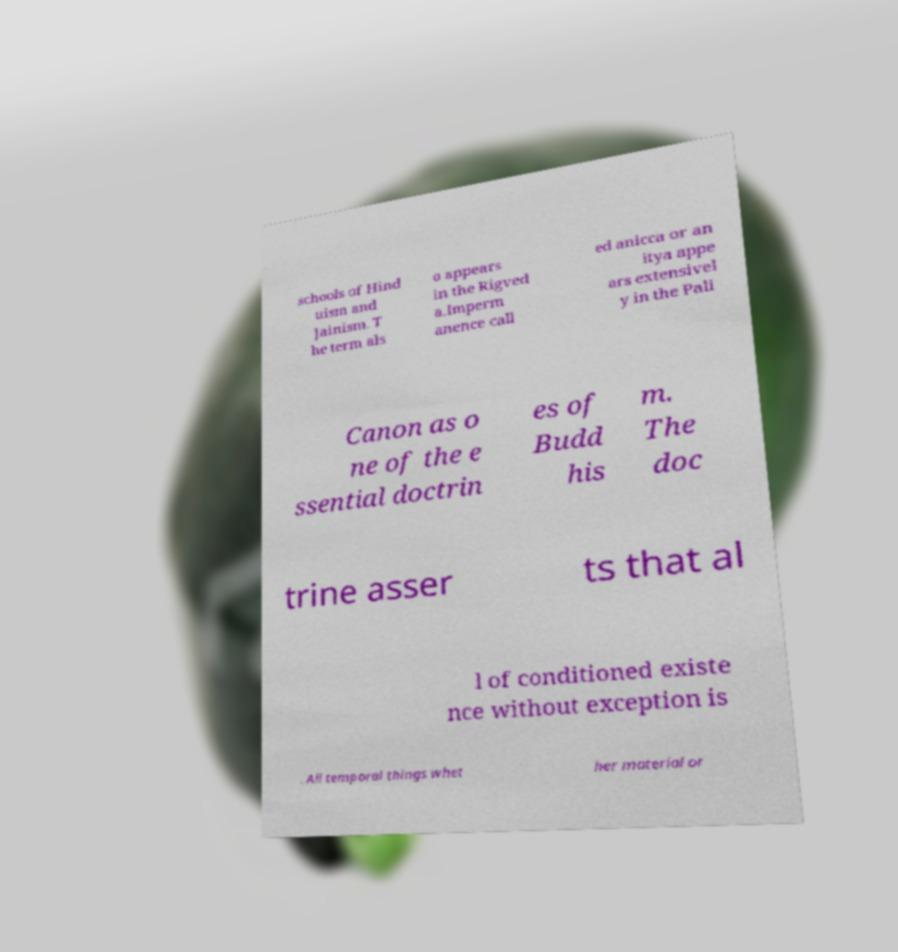There's text embedded in this image that I need extracted. Can you transcribe it verbatim? schools of Hind uism and Jainism. T he term als o appears in the Rigved a.Imperm anence call ed anicca or an itya appe ars extensivel y in the Pali Canon as o ne of the e ssential doctrin es of Budd his m. The doc trine asser ts that al l of conditioned existe nce without exception is . All temporal things whet her material or 